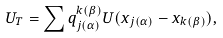Convert formula to latex. <formula><loc_0><loc_0><loc_500><loc_500>U _ { T } = \sum q _ { j ( \alpha ) } ^ { k ( \beta ) } U ( x _ { j ( \alpha ) } - x _ { k ( \beta ) } ) ,</formula> 